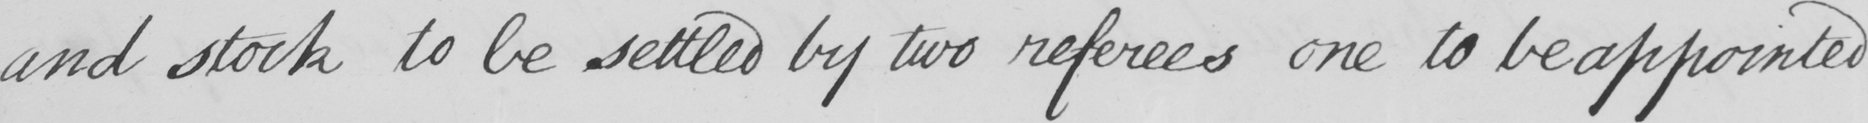Can you read and transcribe this handwriting? and stock to be settled by two referees one to be appointed 